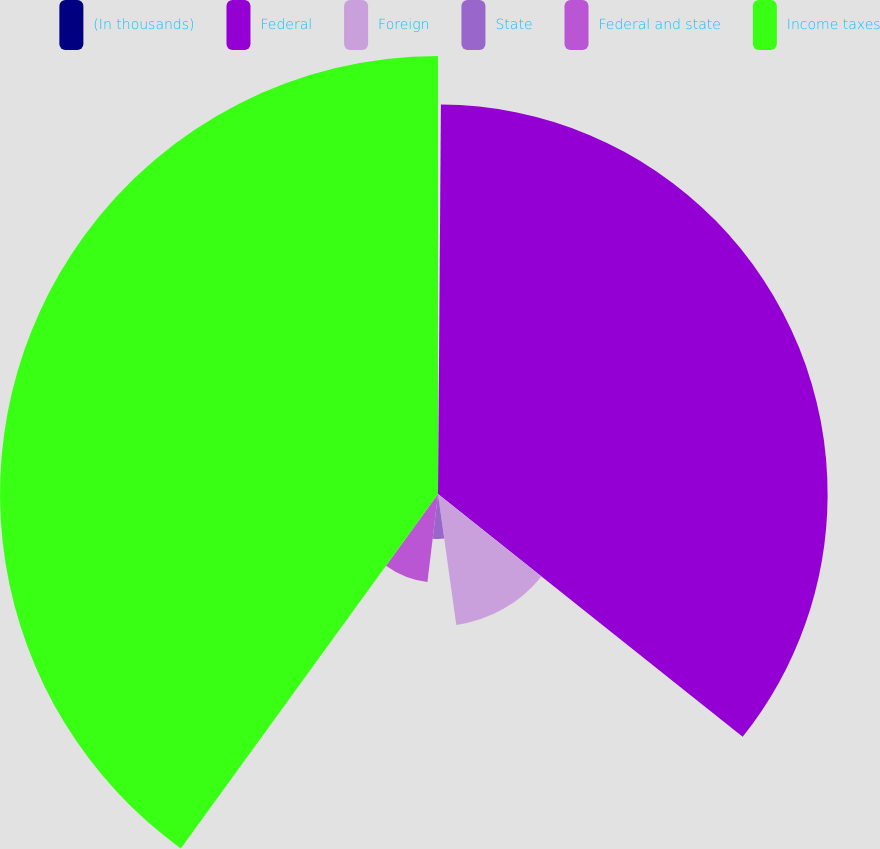<chart> <loc_0><loc_0><loc_500><loc_500><pie_chart><fcel>(In thousands)<fcel>Federal<fcel>Foreign<fcel>State<fcel>Federal and state<fcel>Income taxes<nl><fcel>0.12%<fcel>35.59%<fcel>12.08%<fcel>4.11%<fcel>8.09%<fcel>40.01%<nl></chart> 